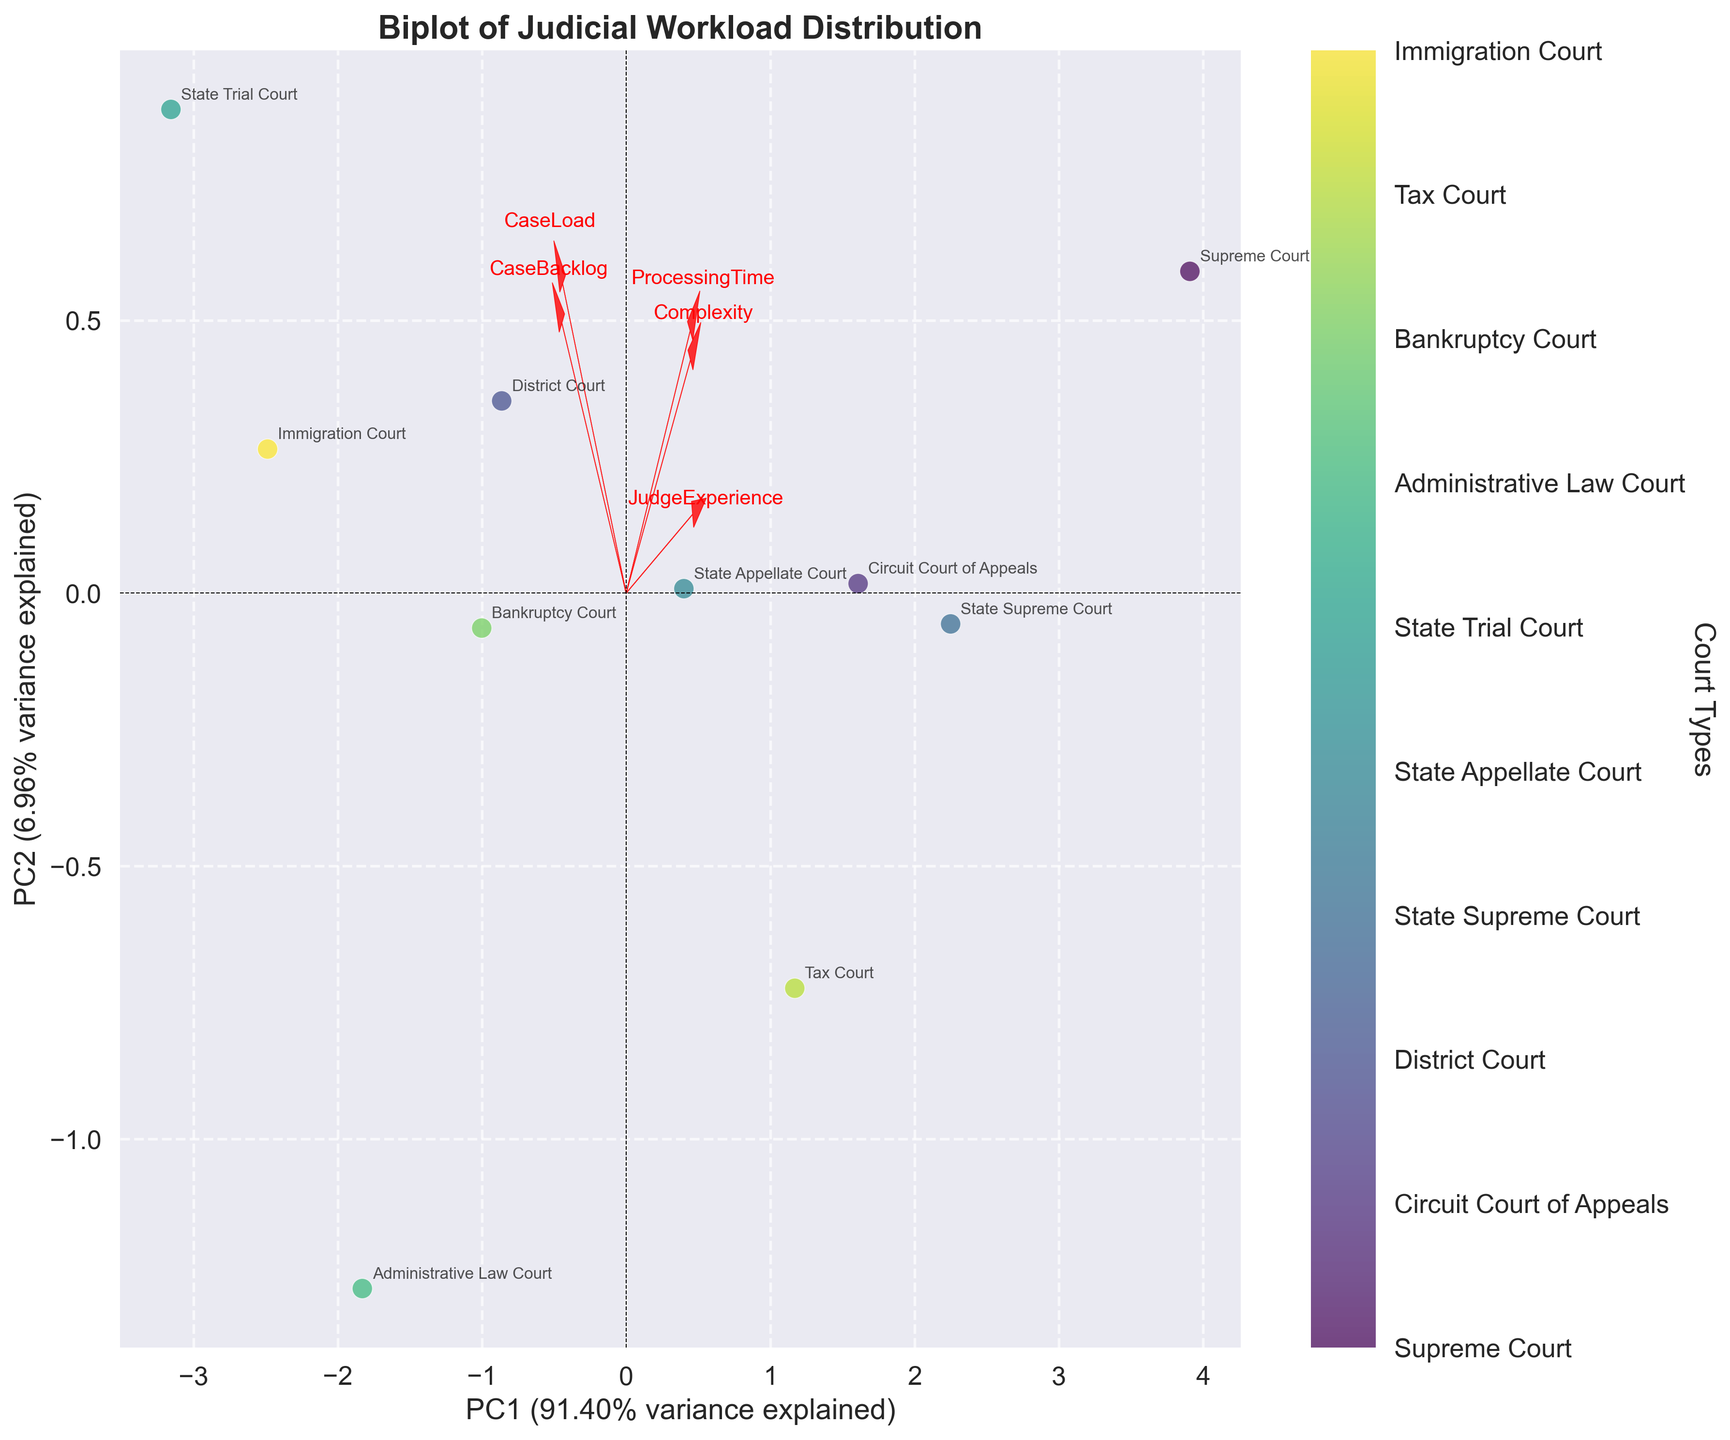What's the title of the figure? The title of the figure is usually at the top center of the plot. In this case, the title reads "Biplot of Judicial Workload Distribution".
Answer: Biplot of Judicial Workload Distribution What are the labels of the x and y axes? The x and y axes labels provide information about the principal components. Here, the x-axis is labeled "PC1" and the y-axis is labeled "PC2", along with their respective explained variances.
Answer: PC1 and PC2 How many courts are represented in the figure? The courts are represented by scattered points on the plot, each annotated with the court's name. Counting these annotations provides the number of courts. There are 10 courts in the plot.
Answer: 10 Which court has the highest value on the first principal component (PC1)? The first principal component is represented by the x-axis. Identify the court furthest to the right on the x-axis to determine which court has the highest value on PC1.
Answer: Bankruptcy Court Which factor appears to align most closely with PC1? The factor alignment is indicated by the arrows pointing from the origin. The factor with the longest arrow in the direction of PC1 shows the strongest alignment. "CaseLoad" has the longest arrow parallel to PC1.
Answer: CaseLoad Which court has the lowest judge experience-related value in the PCA plot? The factor "JudgeExperience" points in a certain direction, find the court furthest from this direction. "State Trial Court" is located opposite to the direction of "JudgeExperience."
Answer: State Trial Court What is the relationship between "ProcessingTime" and "CaseBacklog" as seen in the Biplot? Observe the direction and length of the arrows for "ProcessingTime" and "CaseBacklog". These factors are more aligned, suggesting a positive correlation.
Answer: Positive correlation Which two courts have the most similar workload distribution patterns based on their proximity on the plot? Courts located close to each other on the biplot have similar scores for the principal components, suggesting similar workload distribution patterns. "District Court" and "State Appellate Court" are very close to each other.
Answer: District Court and State Appellate Court 